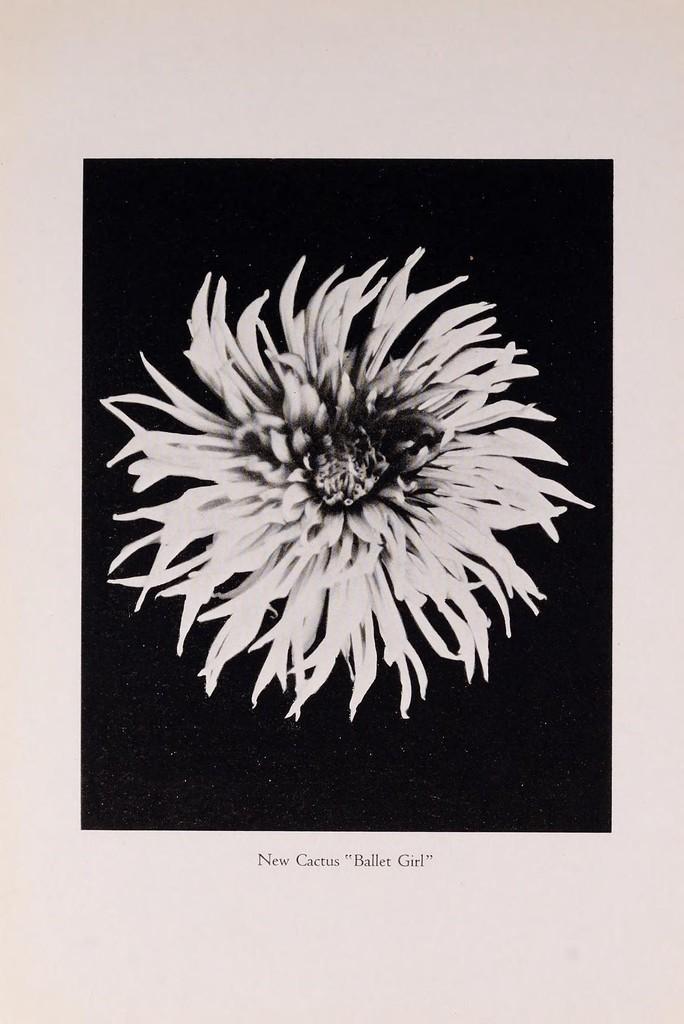In one or two sentences, can you explain what this image depicts? In this image we can see a paper with the flower in the black background. We can also see the text. 